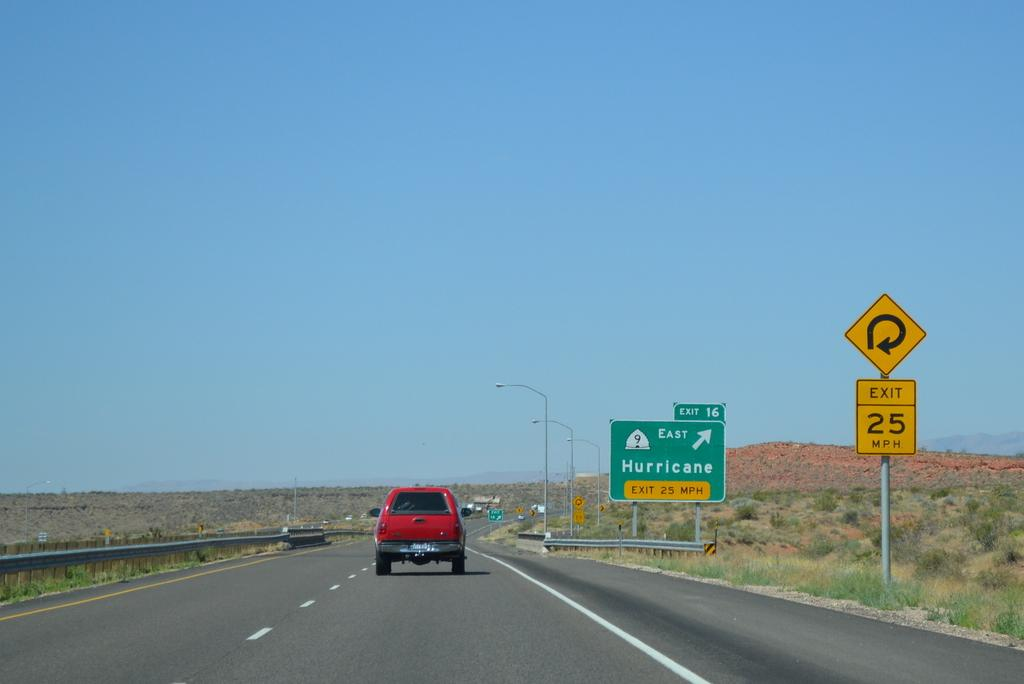Provide a one-sentence caption for the provided image. A red truck drives down the road on a sunny day, passing a sign for the Hurricane exit. 